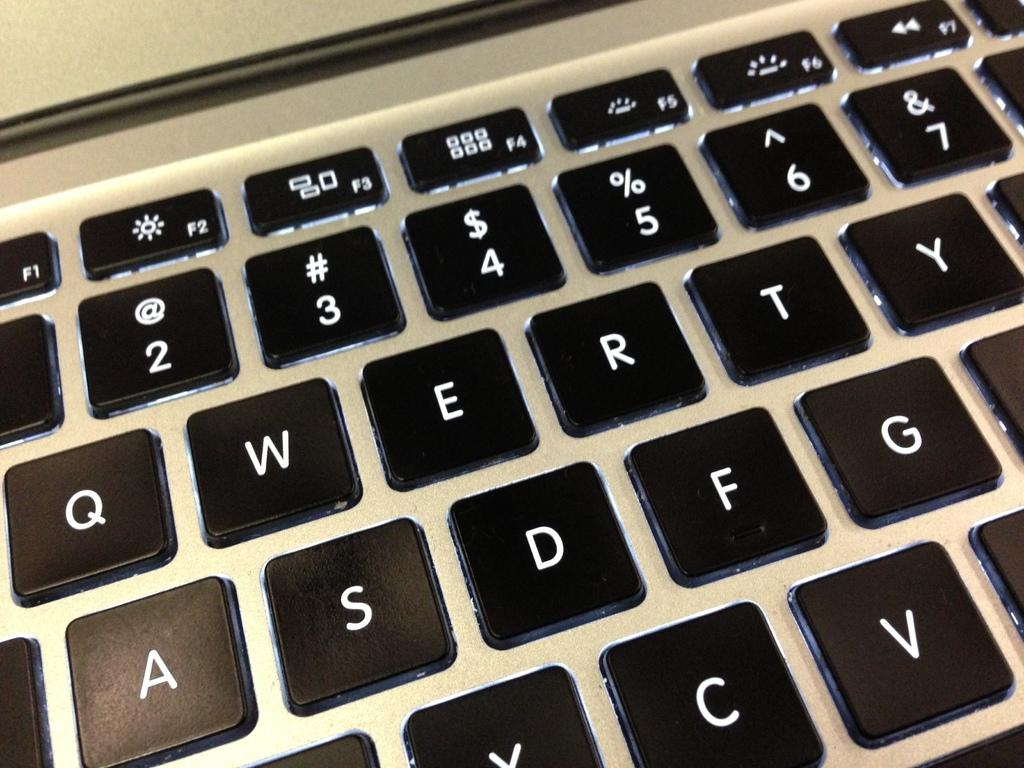What is the main subject of the image? The main subject of the image is a keypad. What type of business is being conducted in the image? There is no indication of a business in the image, as it only features a keypad. Can you describe the weather conditions in the image? The image does not depict any weather conditions, as it only features a keypad. 